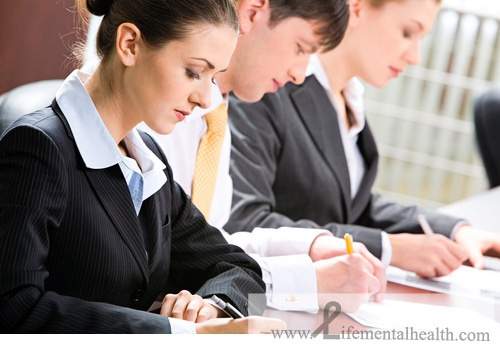Describe the objects in this image and their specific colors. I can see people in maroon, black, lightgray, tan, and gray tones, people in maroon, gray, lightgray, black, and pink tones, people in maroon, white, lightpink, tan, and gray tones, tie in maroon, tan, and beige tones, and chair in maroon, black, gray, and darkgray tones in this image. 